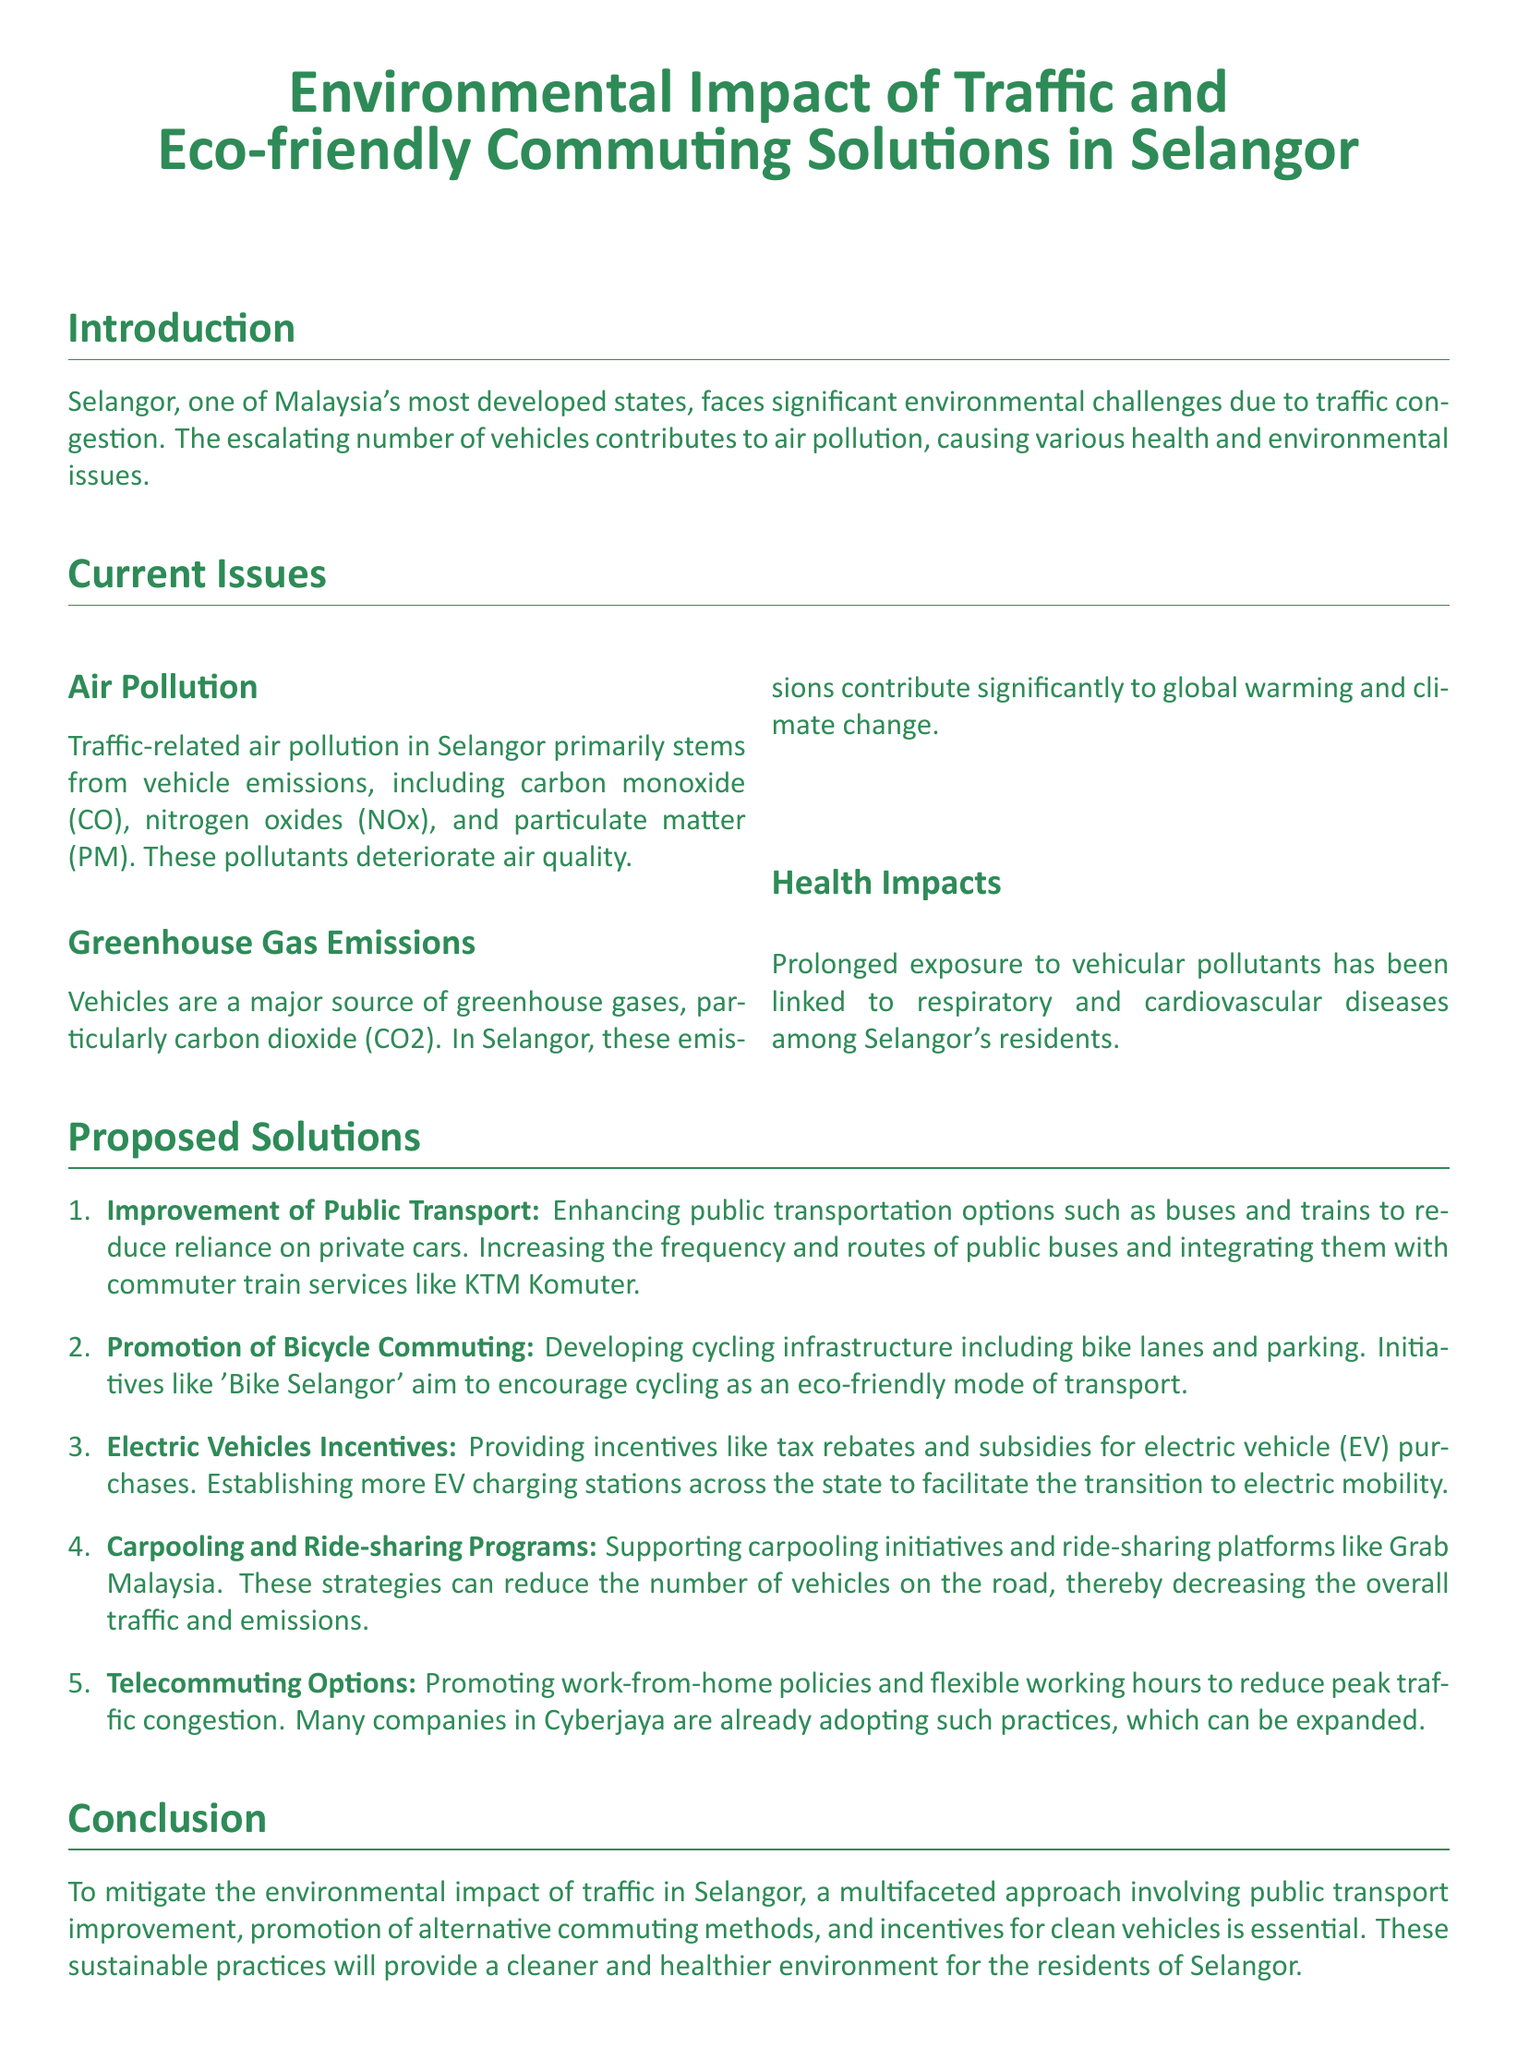what is the primary source of air pollution in Selangor? The primary source of air pollution in Selangor, according to the document, is vehicle emissions.
Answer: vehicle emissions which greenhouse gas is notably emitted by vehicles? The document specifies that carbon dioxide (CO2) is a significant greenhouse gas emitted by vehicles.
Answer: carbon dioxide name one health impact of traffic-related air pollution. The document mentions respiratory diseases as one health impact.
Answer: respiratory diseases what is one initiative to promote bicycle commuting mentioned in the report? The report refers to the initiative 'Bike Selangor' to promote bicycle commuting.
Answer: Bike Selangor how many proposed solutions are listed in the report? The report lists five proposed solutions to address traffic-related environmental issues.
Answer: five which type of vehicles are incentivized according to the document? The document states that electric vehicles (EVs) are incentivized for cleaner commuting.
Answer: electric vehicles what is a suggested benefit of telecommuting options? The report mentions that telecommuting reduces peak traffic congestion.
Answer: reduces peak traffic congestion what is the main goal of the eco-friendly commuting initiatives? The document states that the main goal is to mitigate the environmental impact of traffic.
Answer: mitigate the environmental impact of traffic 